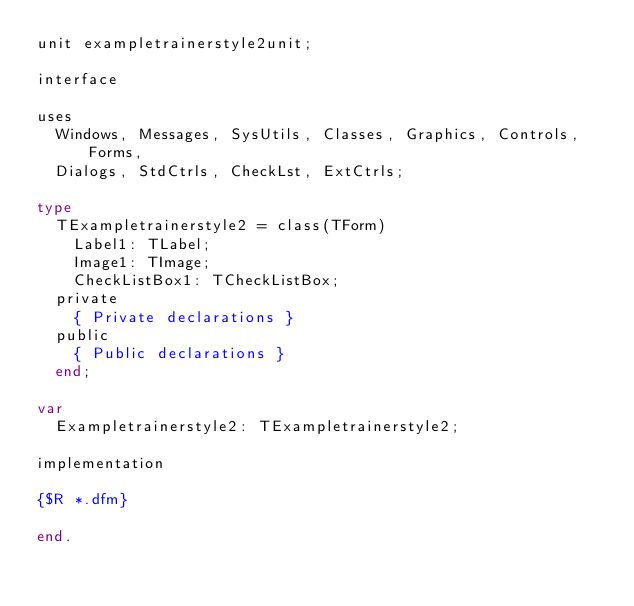Convert code to text. <code><loc_0><loc_0><loc_500><loc_500><_Pascal_>unit exampletrainerstyle2unit;

interface

uses
  Windows, Messages, SysUtils, Classes, Graphics, Controls, Forms,
  Dialogs, StdCtrls, CheckLst, ExtCtrls;

type
  TExampletrainerstyle2 = class(TForm)
    Label1: TLabel;
    Image1: TImage;
    CheckListBox1: TCheckListBox;
  private
    { Private declarations }
  public
    { Public declarations }
  end;

var
  Exampletrainerstyle2: TExampletrainerstyle2;

implementation

{$R *.dfm}

end.
</code> 